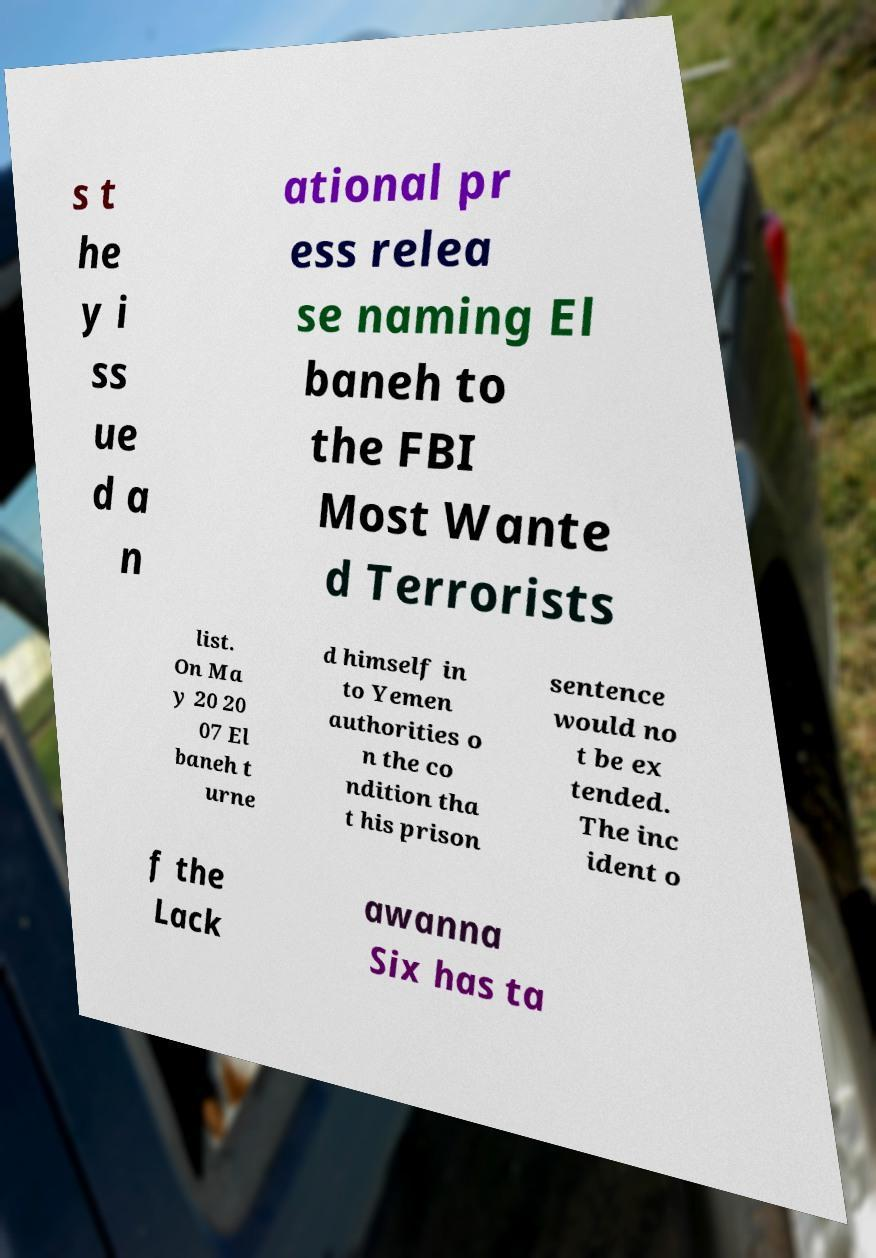I need the written content from this picture converted into text. Can you do that? s t he y i ss ue d a n ational pr ess relea se naming El baneh to the FBI Most Wante d Terrorists list. On Ma y 20 20 07 El baneh t urne d himself in to Yemen authorities o n the co ndition tha t his prison sentence would no t be ex tended. The inc ident o f the Lack awanna Six has ta 